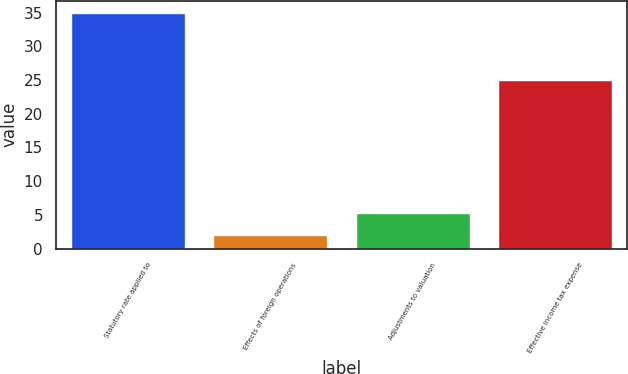Convert chart. <chart><loc_0><loc_0><loc_500><loc_500><bar_chart><fcel>Statutory rate applied to<fcel>Effects of foreign operations<fcel>Adjustments to valuation<fcel>Effective income tax expense<nl><fcel>35<fcel>2<fcel>5.3<fcel>25<nl></chart> 